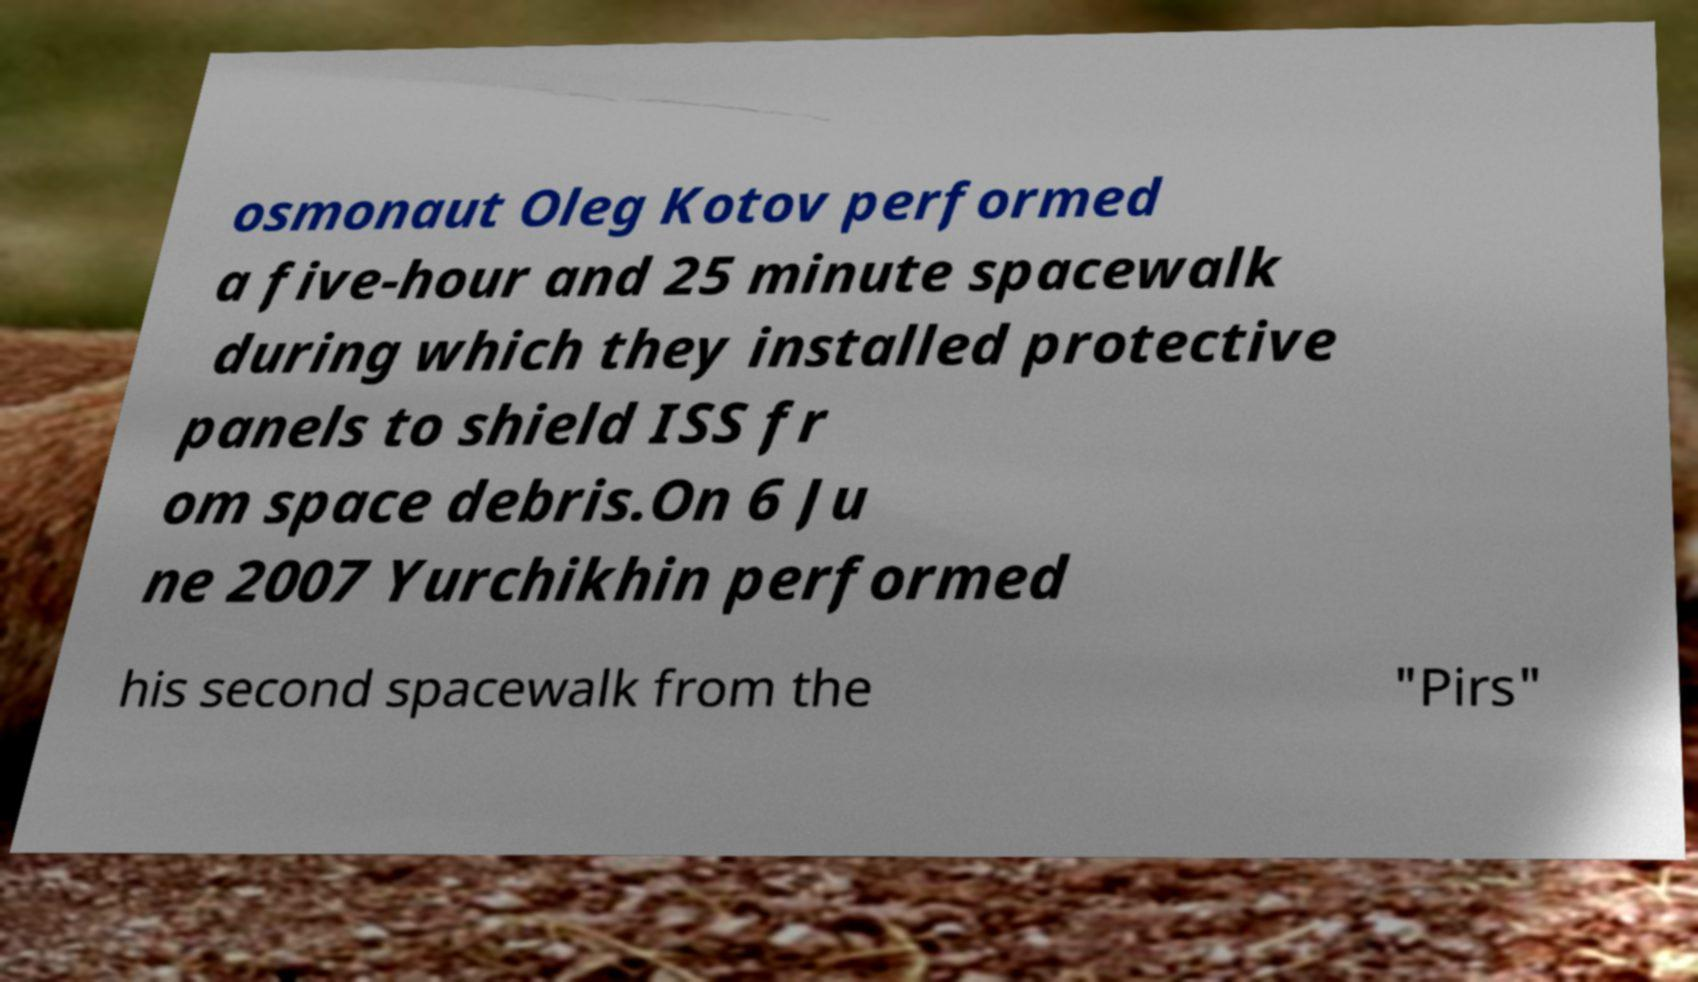I need the written content from this picture converted into text. Can you do that? osmonaut Oleg Kotov performed a five-hour and 25 minute spacewalk during which they installed protective panels to shield ISS fr om space debris.On 6 Ju ne 2007 Yurchikhin performed his second spacewalk from the "Pirs" 